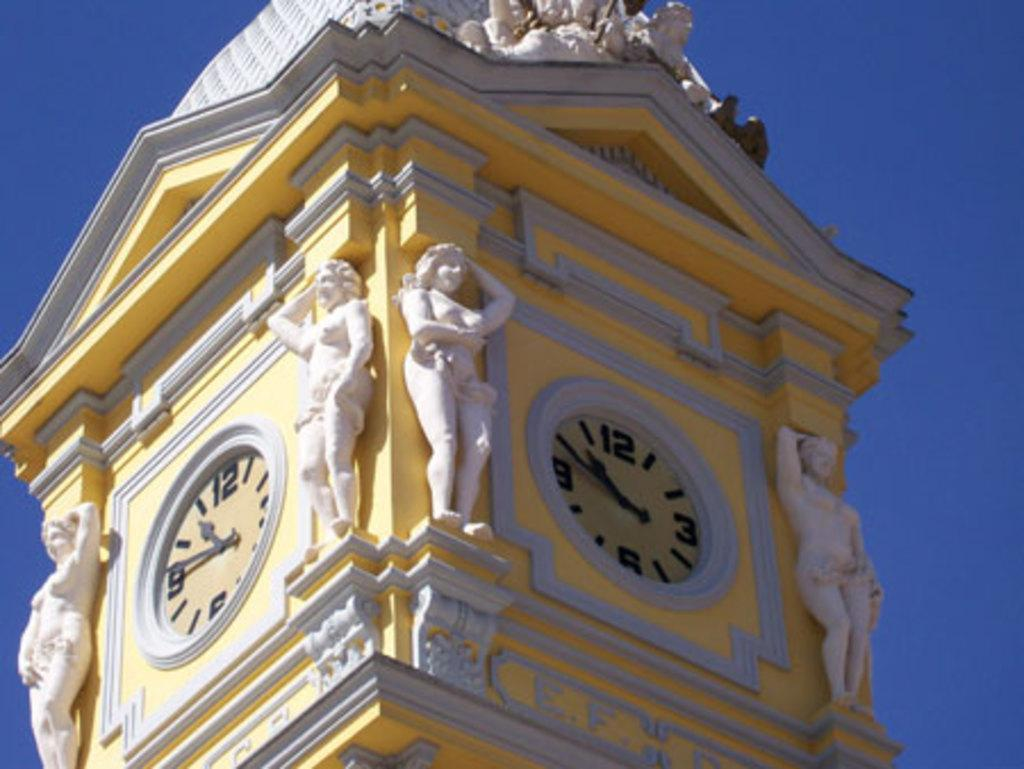What type of structure is present in the image? There is a building in the image. What features can be seen on the building? The building has clocks and sculptures on it. What can be seen in the background of the image? The sky is visible in the image. What type of rake is being used by the writer in the image? There is no rake or writer present in the image; it features a building with clocks and sculptures. Is the crook visible in the image? There is no crook present in the image. 